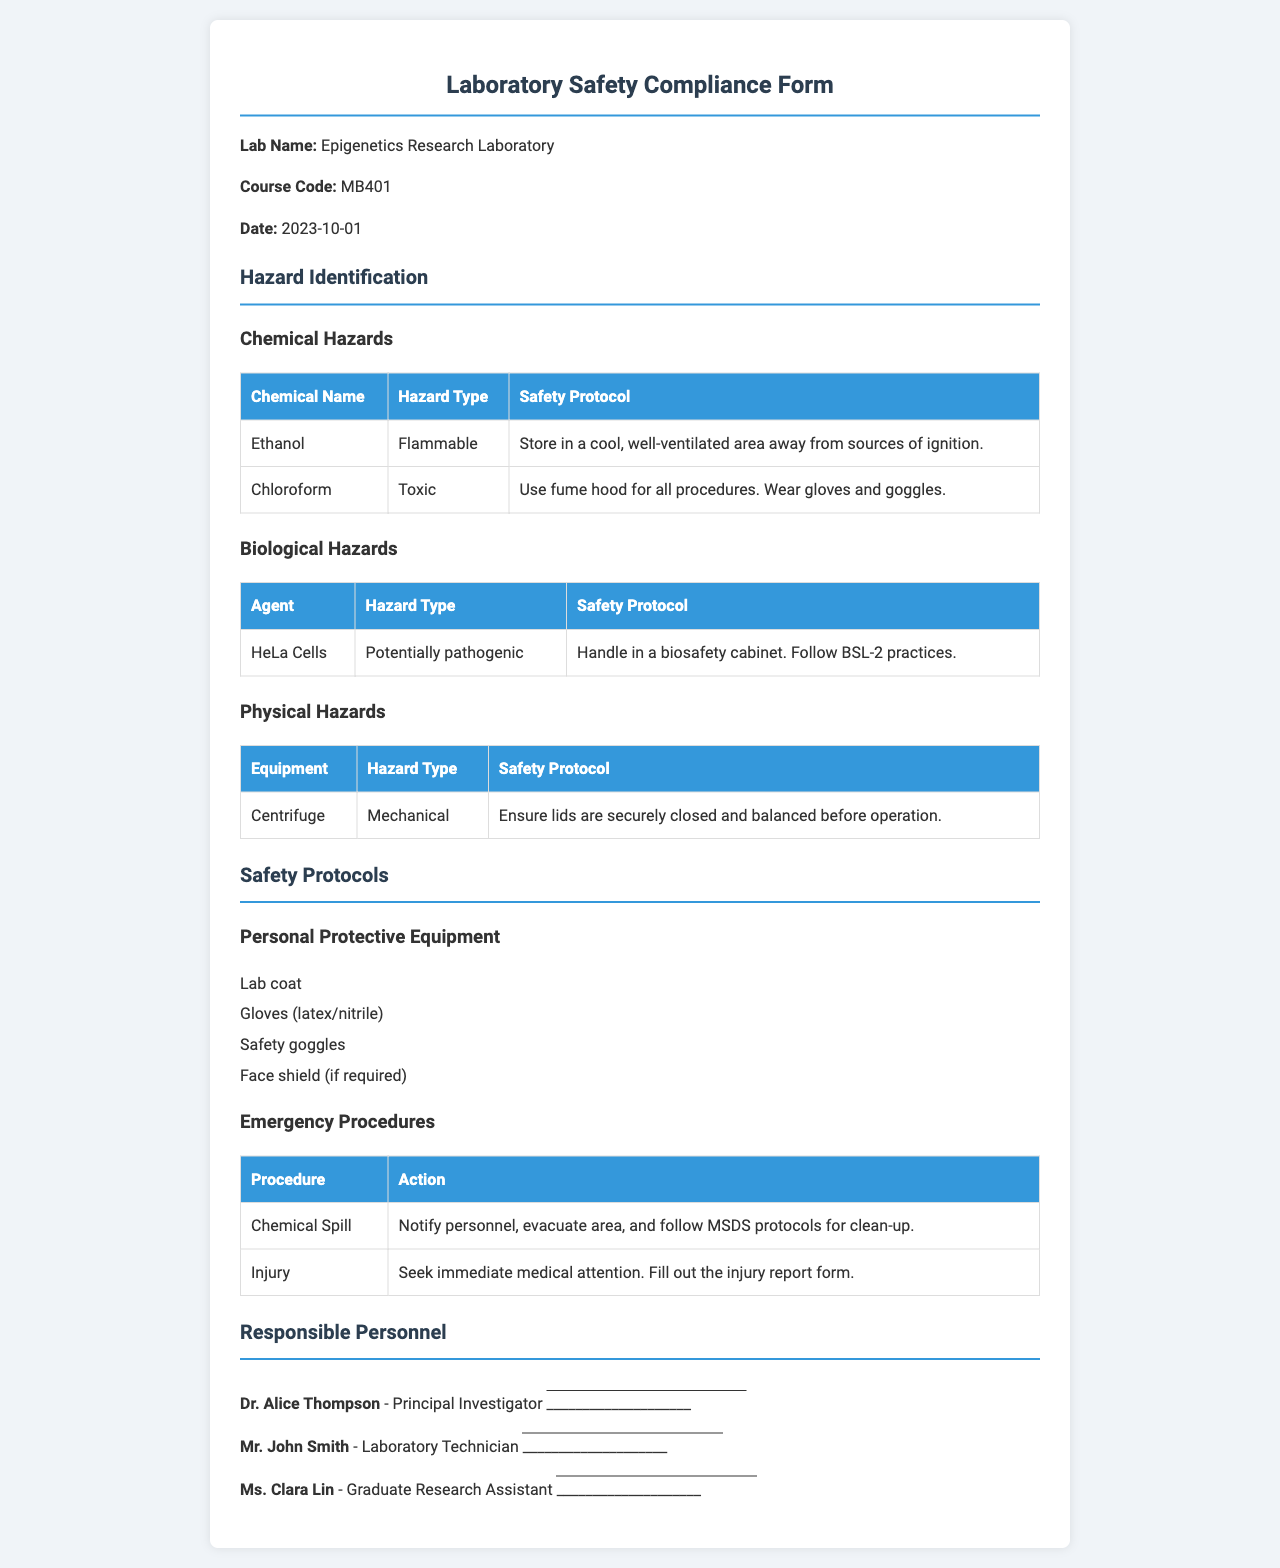What is the lab name? The lab name is explicitly stated at the beginning of the document.
Answer: Epigenetics Research Laboratory What type of hazard is associated with ethanol? The document lists specific hazards for each chemical, including ethanol.
Answer: Flammable What safety protocol is recommended for chloroform? The document indicates the recommended safety protocol for chloroform explicitly.
Answer: Use fume hood for all procedures. Wear gloves and goggles How many types of biological hazards are listed? The document mentions one specific biological hazard type.
Answer: 1 Who is the principal investigator? The name of the principal investigator is provided in the responsible personnel section.
Answer: Dr. Alice Thompson What should be worn as personal protective equipment? The document lists several items of personal protective equipment specifically.
Answer: Lab coat, gloves, safety goggles, face shield What action should be taken in case of a chemical spill? The document states the action to be taken for chemical spills clearly.
Answer: Notify personnel, evacuate area, and follow MSDS protocols for clean-up What date is the form dated? The date of the form is directly mentioned in the document.
Answer: 2023-10-01 